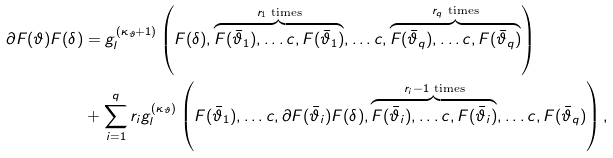Convert formula to latex. <formula><loc_0><loc_0><loc_500><loc_500>\partial F ( \vartheta ) F ( \delta ) & = g _ { l } ^ { ( \kappa _ { \vartheta } + 1 ) } \left ( F ( \delta ) , \overbrace { F ( \bar { \vartheta } _ { 1 } ) , \dots c , F ( \bar { \vartheta } _ { 1 } ) } ^ { r _ { 1 } \text { times} } , \dots c , \overbrace { F ( \bar { \vartheta } _ { q } ) , \dots c , F ( \bar { \vartheta } _ { q } ) } ^ { r _ { q } \text { times} } \right ) \\ & + \sum _ { i = 1 } ^ { q } r _ { i } g _ { l } ^ { ( \kappa _ { \vartheta } ) } \left ( F ( \bar { \vartheta } _ { 1 } ) , \dots c , \partial F ( \bar { \vartheta } _ { i } ) F ( \delta ) , \overbrace { F ( \bar { \vartheta } _ { i } ) , \dots c , F ( \bar { \vartheta } _ { i } ) } ^ { r _ { i } - 1 \text { times} } , \dots c , F ( { \bar { \vartheta } _ { q } } ) \right ) ,</formula> 